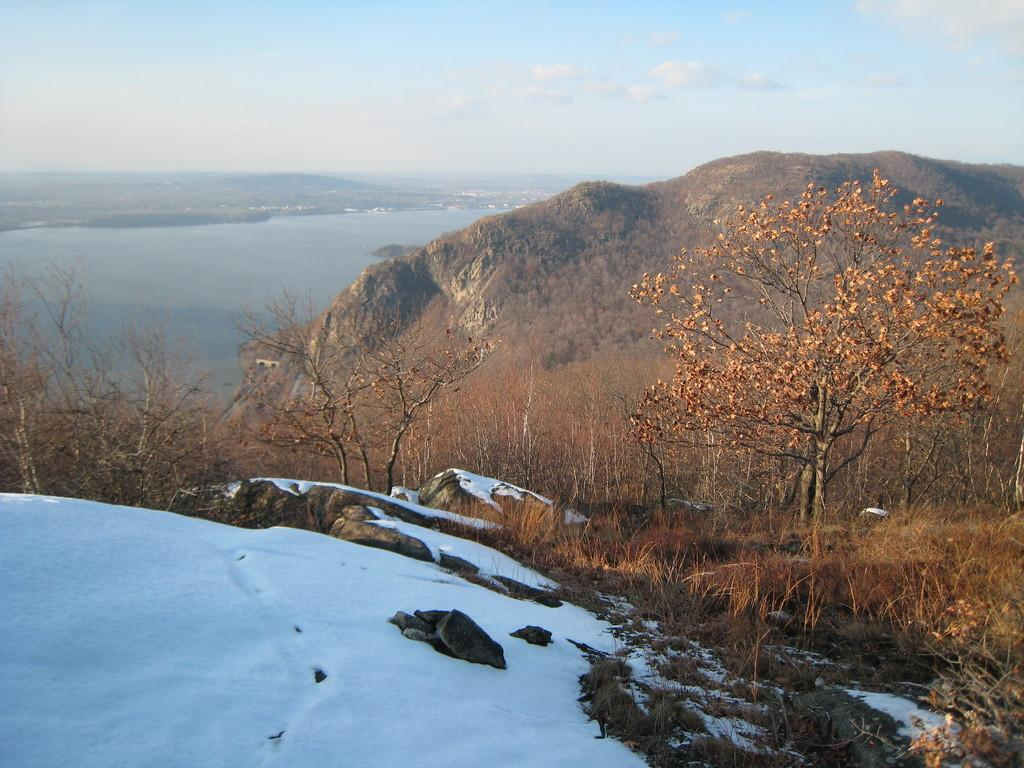What type of natural landform can be seen in the image? There are mountains in the image. What other natural elements are present in the image? There are trees in the image. Which mountain has a specific characteristic? One mountain is covered with snow. What body of water is visible in the image? There is a lake in the background of the image. What part of the natural environment is visible in the image? The sky is visible in the image. Can you hear the horn of a vehicle in the image? There is no reference to a vehicle or a horn in the image, so it is not possible to answer that question. 